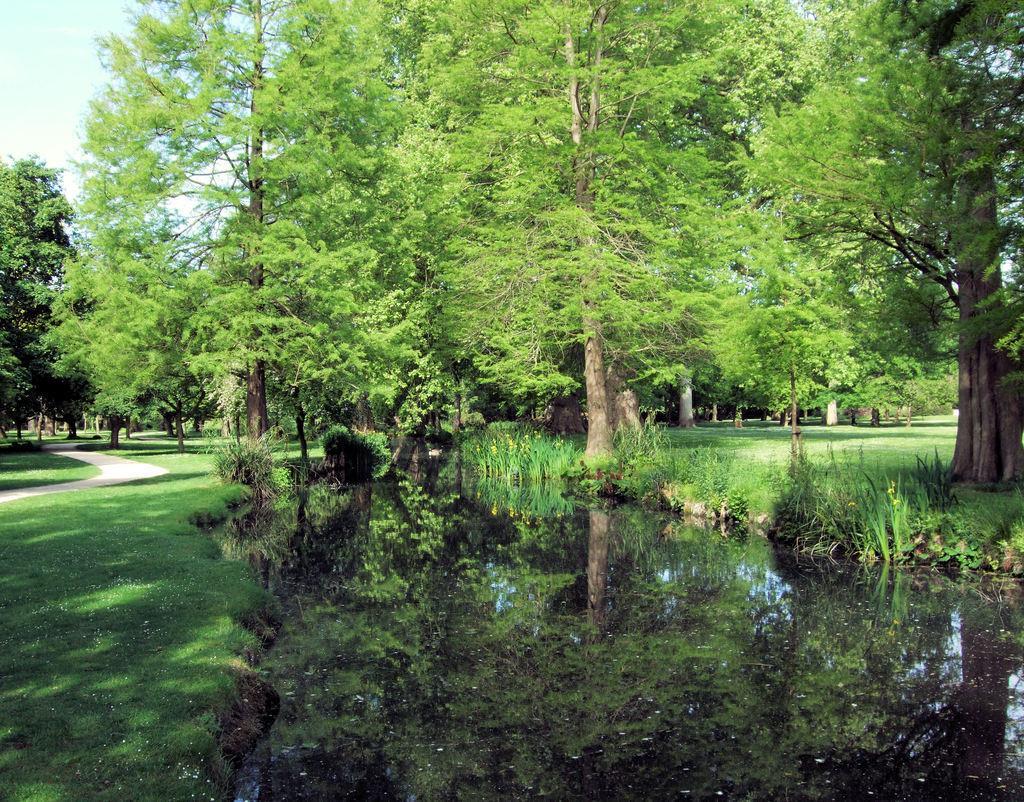Could you give a brief overview of what you see in this image? In this image there is full of greenery. There is grass. There are trees and plants. There is a path on the left side. There is a sky. 